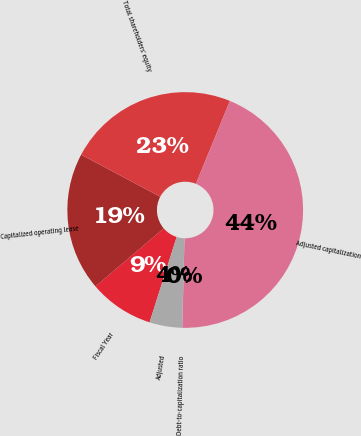<chart> <loc_0><loc_0><loc_500><loc_500><pie_chart><fcel>Fiscal Year<fcel>Capitalized operating lease<fcel>Total shareholders' equity<fcel>Adjusted capitalization<fcel>Debt-to-capitalization ratio<fcel>Adjusted<nl><fcel>8.88%<fcel>19.0%<fcel>23.42%<fcel>44.2%<fcel>0.04%<fcel>4.46%<nl></chart> 